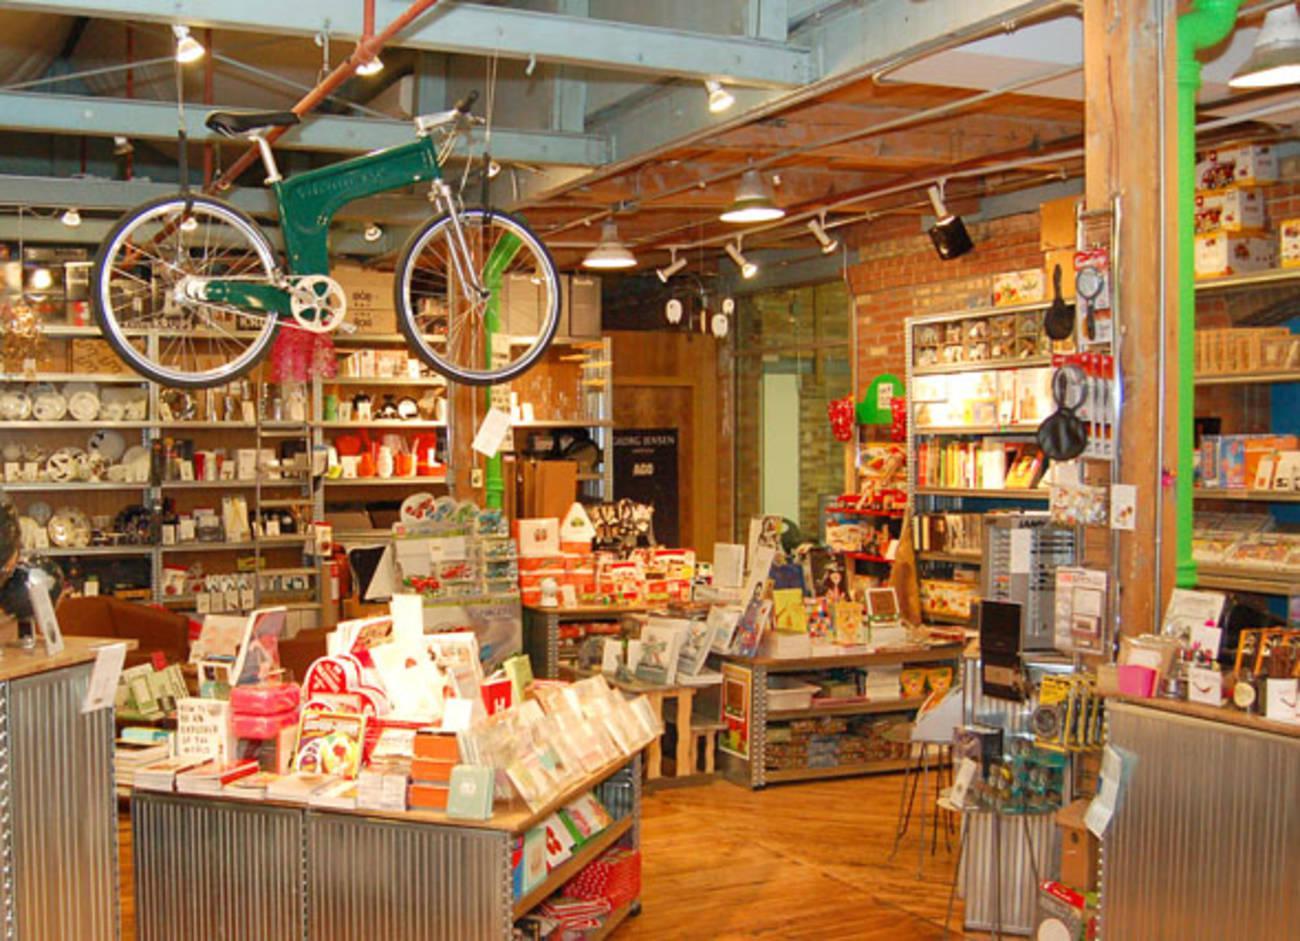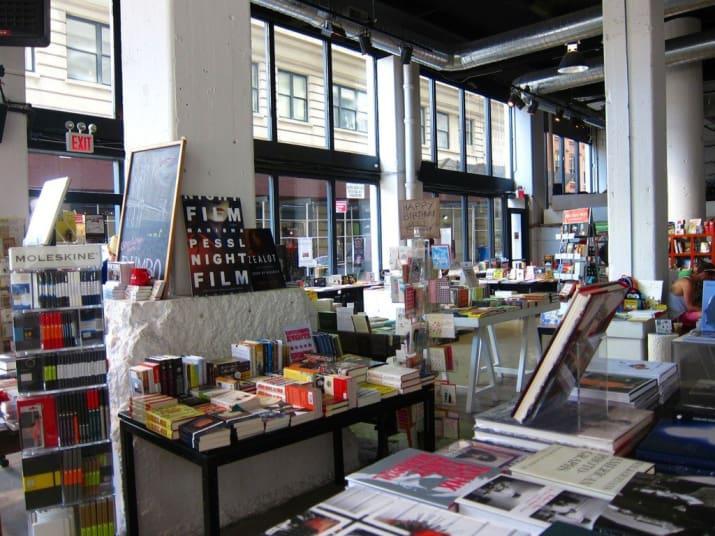The first image is the image on the left, the second image is the image on the right. Considering the images on both sides, is "In the image on the right, there is at least one table that holds some books propped up on bookstands." valid? Answer yes or no. Yes. The first image is the image on the left, the second image is the image on the right. Analyze the images presented: Is the assertion "In at least one image there is an empty bookstore  with table that has at least 30 books on it." valid? Answer yes or no. Yes. 